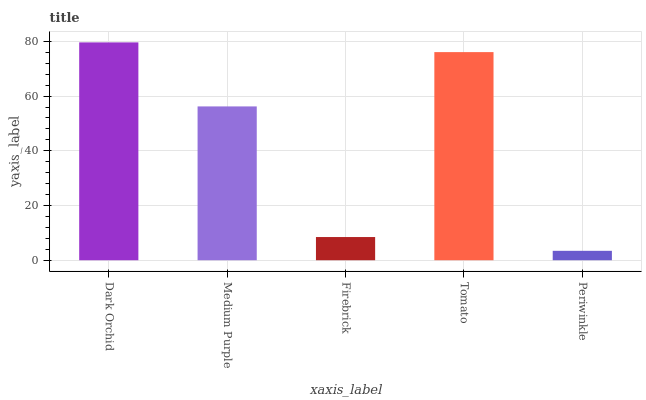Is Periwinkle the minimum?
Answer yes or no. Yes. Is Dark Orchid the maximum?
Answer yes or no. Yes. Is Medium Purple the minimum?
Answer yes or no. No. Is Medium Purple the maximum?
Answer yes or no. No. Is Dark Orchid greater than Medium Purple?
Answer yes or no. Yes. Is Medium Purple less than Dark Orchid?
Answer yes or no. Yes. Is Medium Purple greater than Dark Orchid?
Answer yes or no. No. Is Dark Orchid less than Medium Purple?
Answer yes or no. No. Is Medium Purple the high median?
Answer yes or no. Yes. Is Medium Purple the low median?
Answer yes or no. Yes. Is Tomato the high median?
Answer yes or no. No. Is Periwinkle the low median?
Answer yes or no. No. 